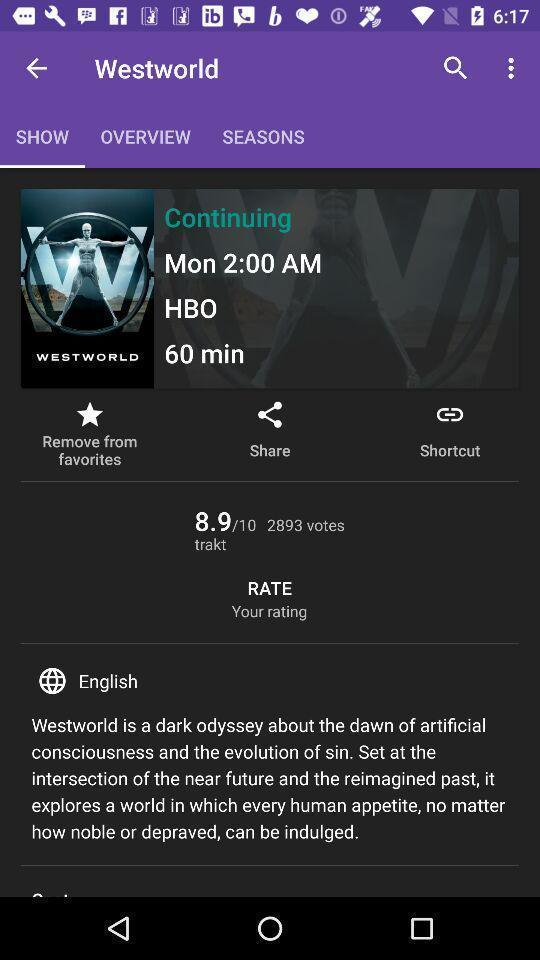Describe this image in words. Page showing various options in a movie app. 